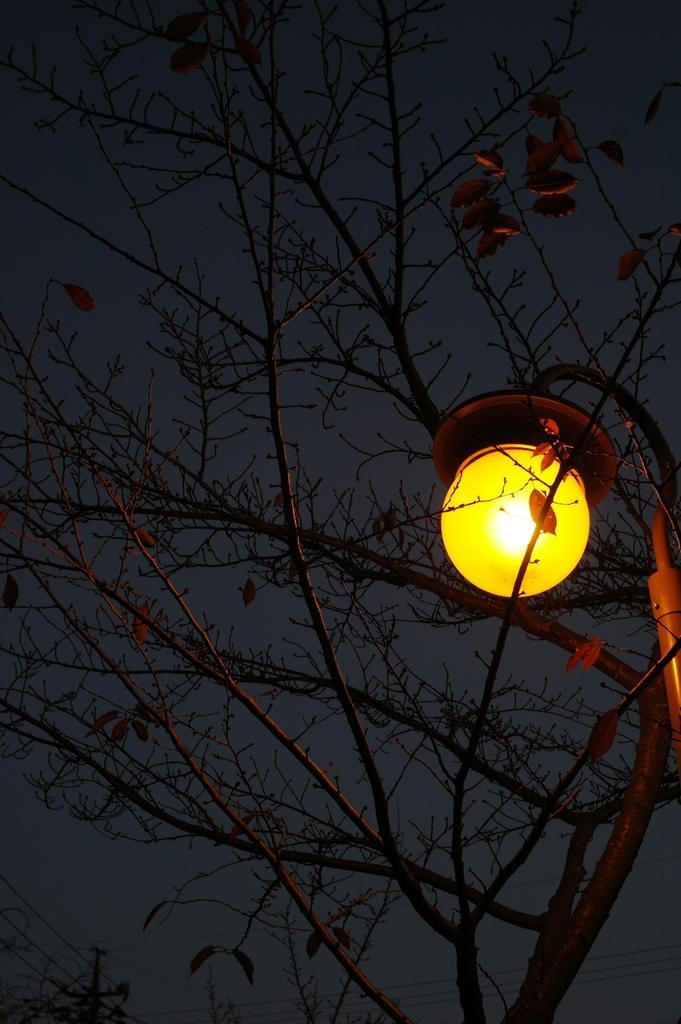How would you summarize this image in a sentence or two? In this image I can see a tree and near it I can see a light. On the bottom left corner of this image I can see a pole and few wires. 